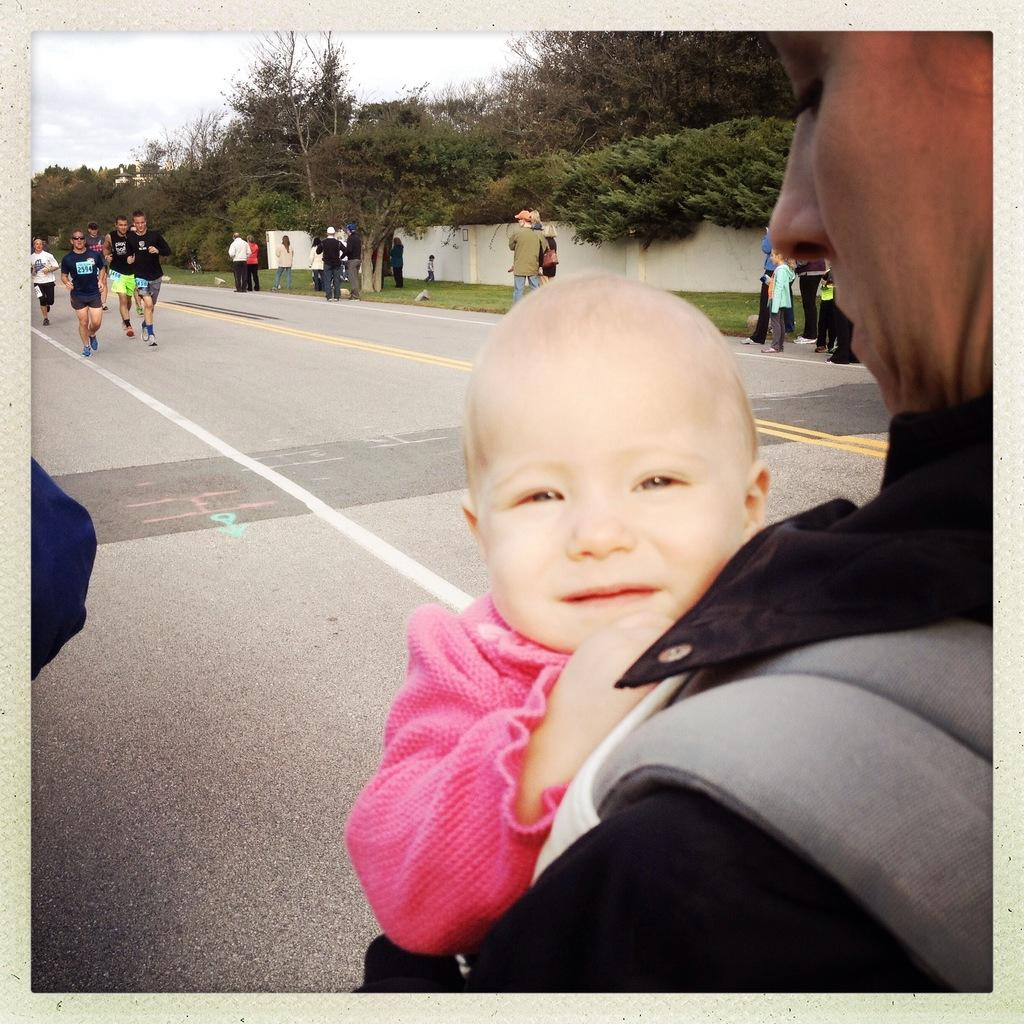What is happening with the group of people in the image? There is a group of people standing on the ground in the image. Can you describe the woman in the group? One woman is carrying a baby in her hands. What can be seen in the background of the image? There is a wall and a group of trees in the background of the image. What is visible above the wall and trees? The sky is visible in the background of the image. How much wealth does the grape in the image represent? There is no grape present in the image, so it cannot represent any wealth. 